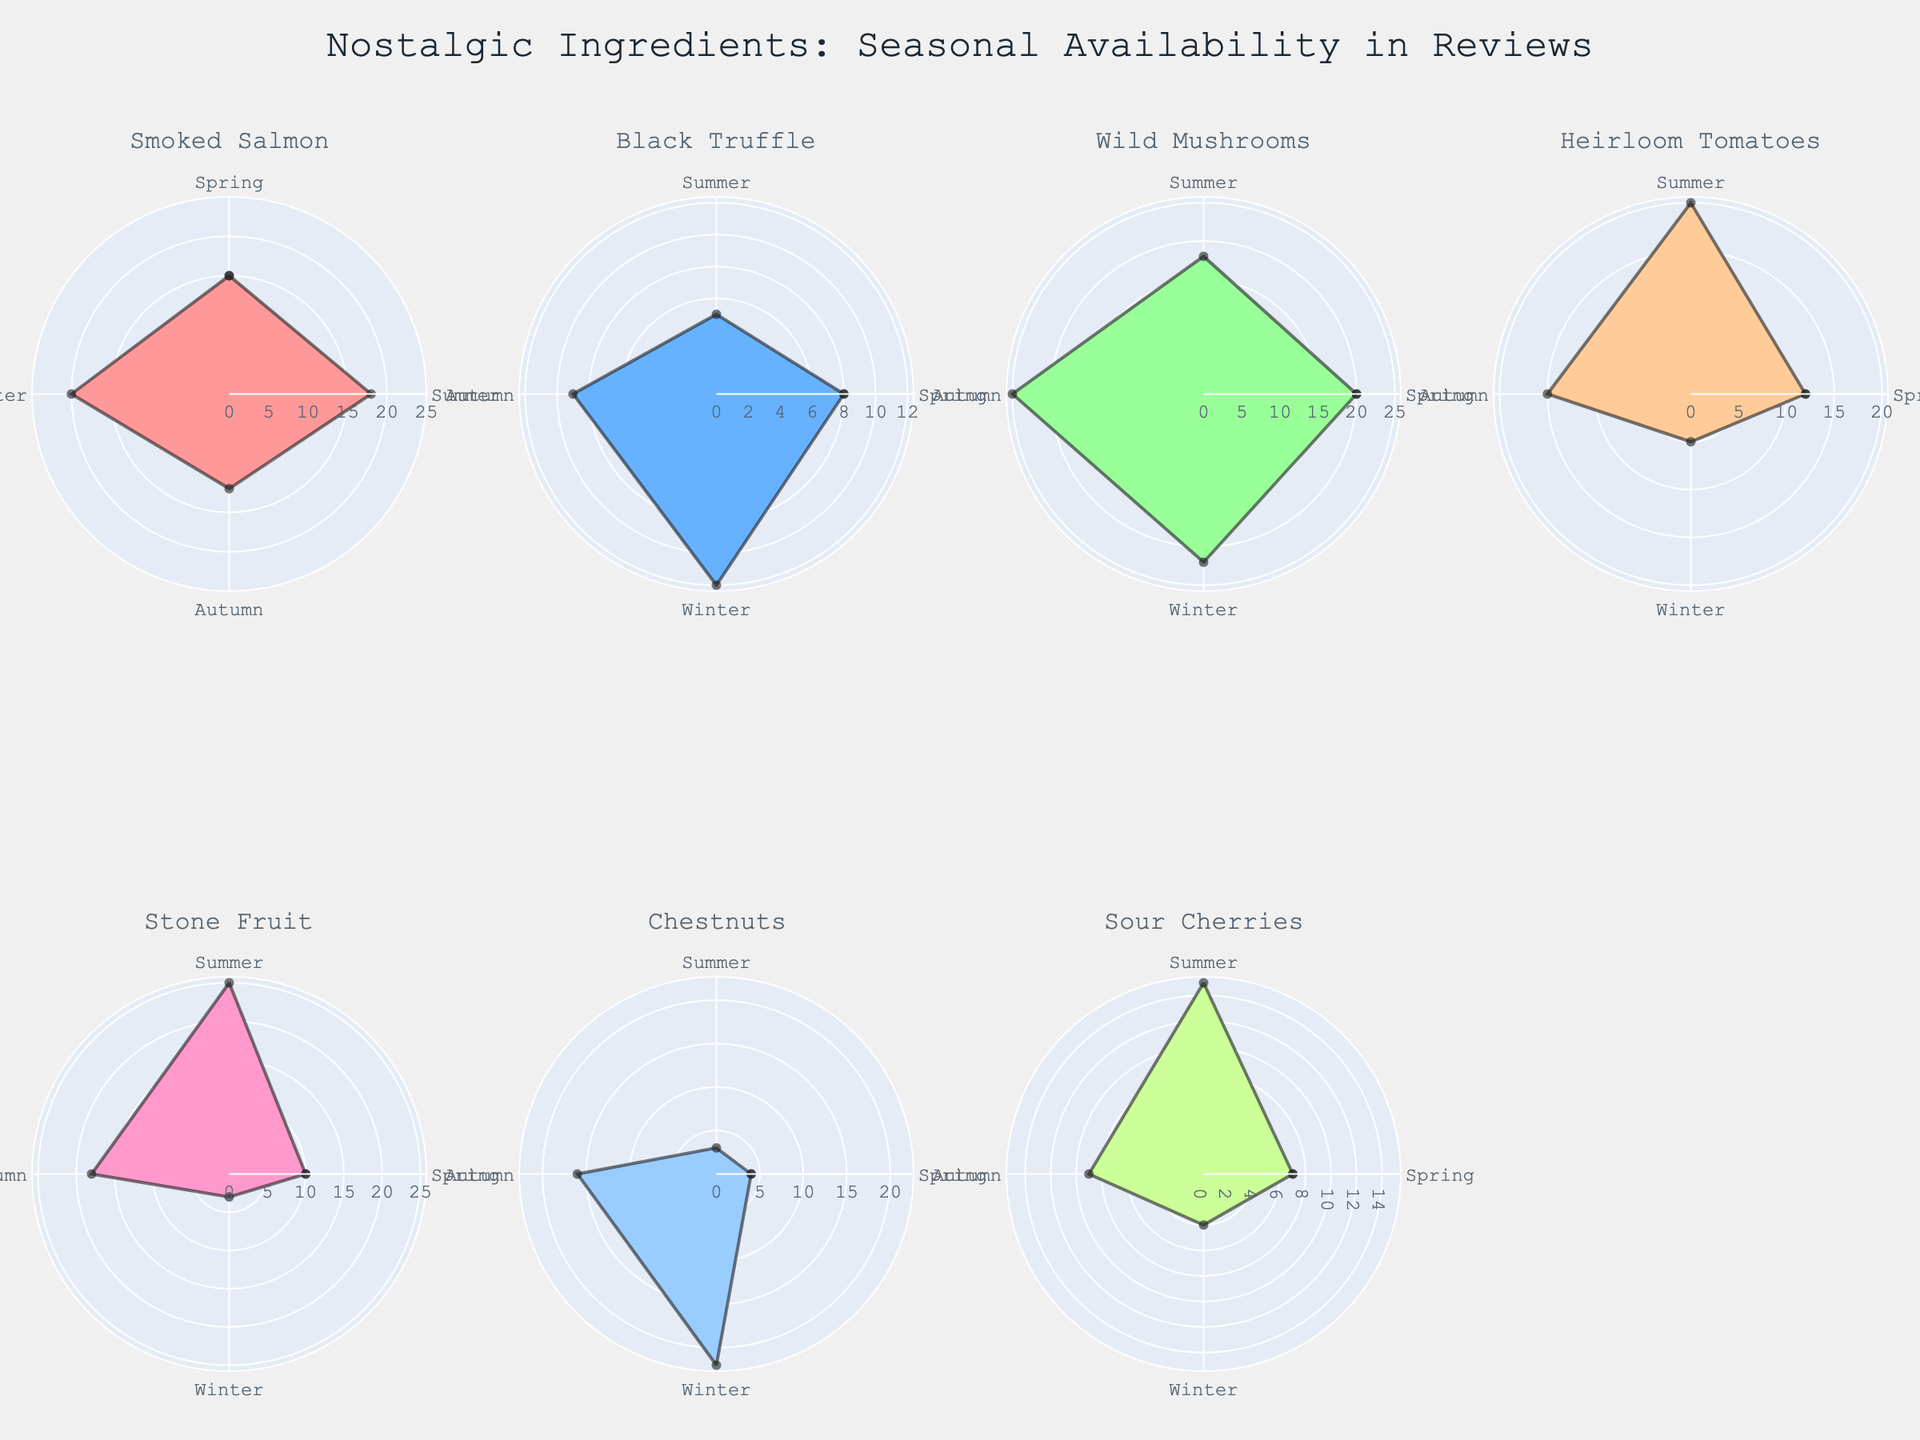Which ingredient has the highest count in reviews for Winter? By examining the subplots for Winter, we observe the counts for each ingredient. Smoked Salmon reaches the peak count of 20 reviews in Winter. Other ingredients have lower counts in Winter compared to Smoked Salmon.
Answer: Smoked Salmon Which two ingredients both have their peak count of reviews in Summer? Reviewing each subplot for Summer, we see the count of reviews for all ingredients. Both Stone Fruit and Heirloom Tomatoes reach their maximum counts of 25 and 20 reviews, respectively, in Summer.
Answer: Stone Fruit and Heirloom Tomatoes What is the average count of reviews for Wild Mushrooms across all seasons? The counts for Wild Mushrooms across the seasons are: Spring (20), Summer (18), Autumn (25), and Winter (22). Summing these (20 + 18 + 25 + 22 = 85) and then dividing by the number of seasons (4), the average count is 85/4.
Answer: 21.25 During which seasons is Chestnuts' review count less than 10? By looking at the subplot for Chestnuts, we observe that the counts for Spring, Summer, and Winter are all below 10 with counts of 4, 3, and 5 respectively.
Answer: Spring, Summer, and Winter Which ingredient has the least review count in Autumn? Observing all subplots for Autumn, we see that Black Truffle has the lowest count with only 9 reviews in Autumn.
Answer: Black Truffle In which season does Sour Cherries have its highest count in reviews? Examining the Sour Cherries' subplot, the highest count of 15 reviews is seen in Summer. No other season surpasses this count.
Answer: Summer How many ingredients have their peak review counts in Spring? Reviewing the subplots, only Wild Mushrooms have their peak review counts of 20 in Spring. All other ingredients have their peak counts in other seasons.
Answer: 1 What's the difference between the maximum review count and the minimum review count for any single ingredient? Reviewing the subplots: For Stone Fruit, the peak is 25 reviews in Summer, and the minimum is 3 reviews in Winter, giving a difference of 25 - 3.
Answer: 22 Which ingredient has a consistent review count of over 10 throughout all seasons? Reviewing all rose charts, Smoked Salmon consistently has review counts of 15, 18, 12, and 20 across the seasons, all of which are over 10.
Answer: Smoked Salmon 